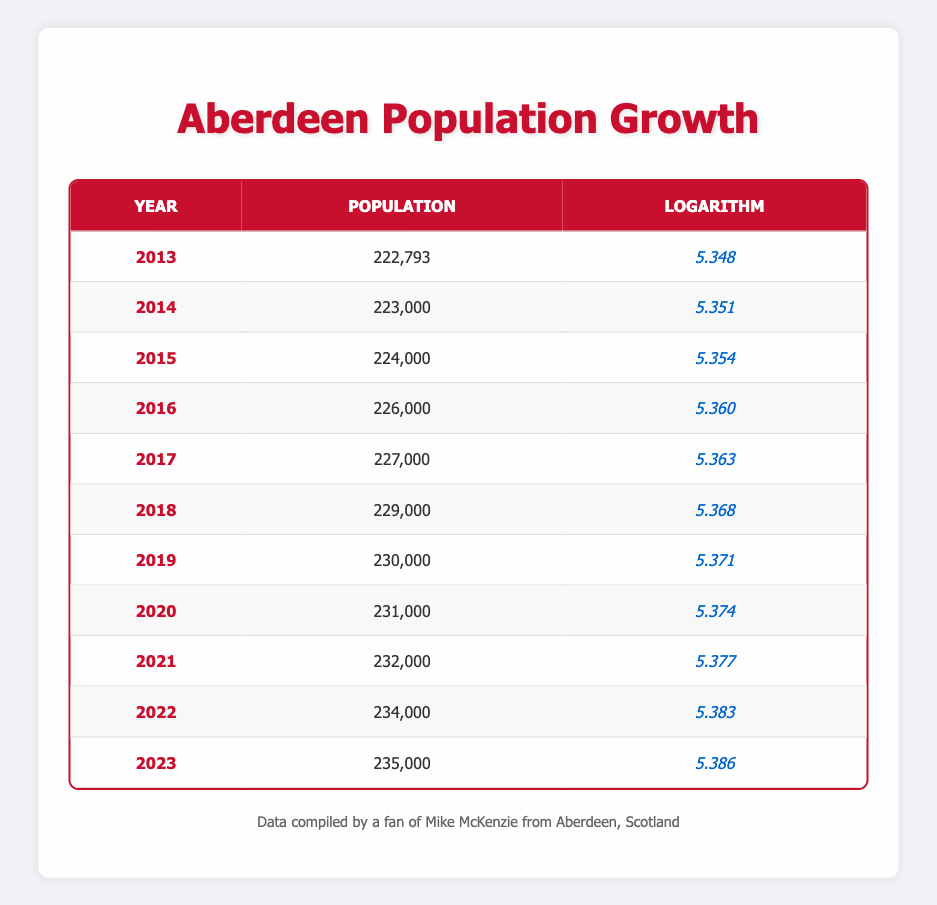What was the population of Aberdeen in 2015? The table shows that the population of Aberdeen in 2015 is listed under the corresponding year row. According to the table, the population is 224,000.
Answer: 224,000 Which year had the highest population according to the table? By examining the population values for each year, the highest population is found in 2023, which is 235,000.
Answer: 2023 What is the difference in population between 2013 and 2022? The population in 2013 is 222,793 and the population in 2022 is 234,000. To find the difference, subtract 222,793 from 234,000, which equals 11,207.
Answer: 11,207 Is the logarithm value for the year 2020 greater than that of 2014? The logarithm for 2020 is 5.374 and for 2014 is 5.351. Since 5.374 is greater than 5.351, the statement is true.
Answer: Yes What is the average population growth from 2013 to 2023? To calculate the average growth, first find the total population growth from 2013 (222,793) to 2023 (235,000), which is 235,000 - 222,793 = 12,207. Next, divide this total growth by the number of years: 12,207 / (2023 - 2013) = 12,207 / 10 = 1,220.7.
Answer: 1,220.7 What was the logarithmic value for the year with the lowest increase in population from the previous year? By comparing the differences in population from each year to the next, the smallest increase is from 2016 to 2017, which is 1,000. The logarithmic value for 2017 is 5.363.
Answer: 5.363 In which year did the population of Aberdeen first surpass 230,000? Looking through the population values, the year when the population first exceeds 230,000 is 2019, with a population of 230,000.
Answer: 2019 What is the total population of Aberdeen from 2013 to 2023? To find the total population, we'll sum the populations for each year from 2013 to 2023: 222793 + 223000 + 224000 + 226000 + 227000 + 229000 + 230000 + 231000 + 232000 + 234000 + 235000 = 2,505,793.
Answer: 2,505,793 